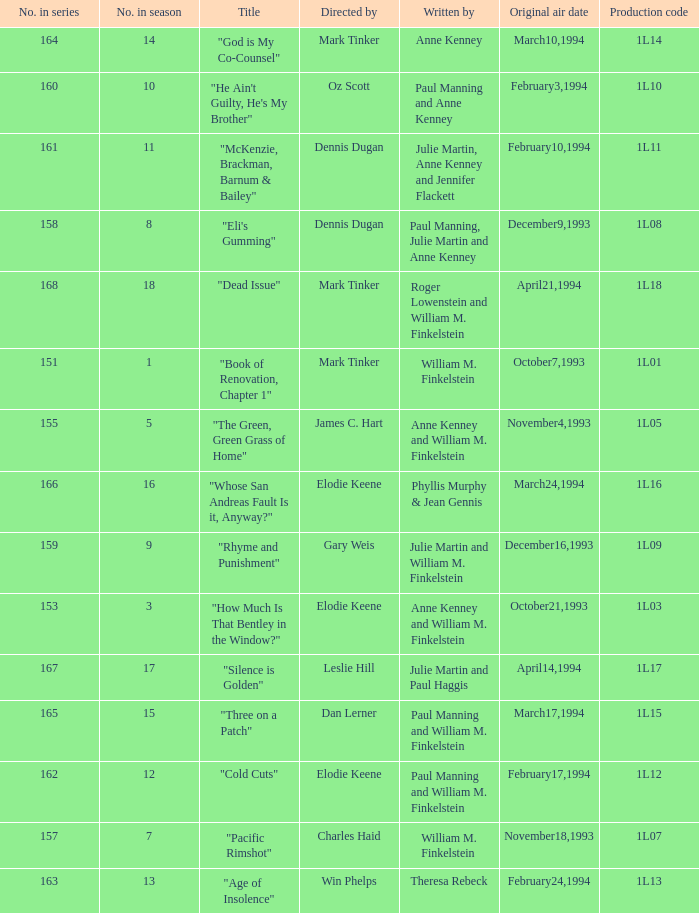Name who directed the production code 1l10 Oz Scott. 